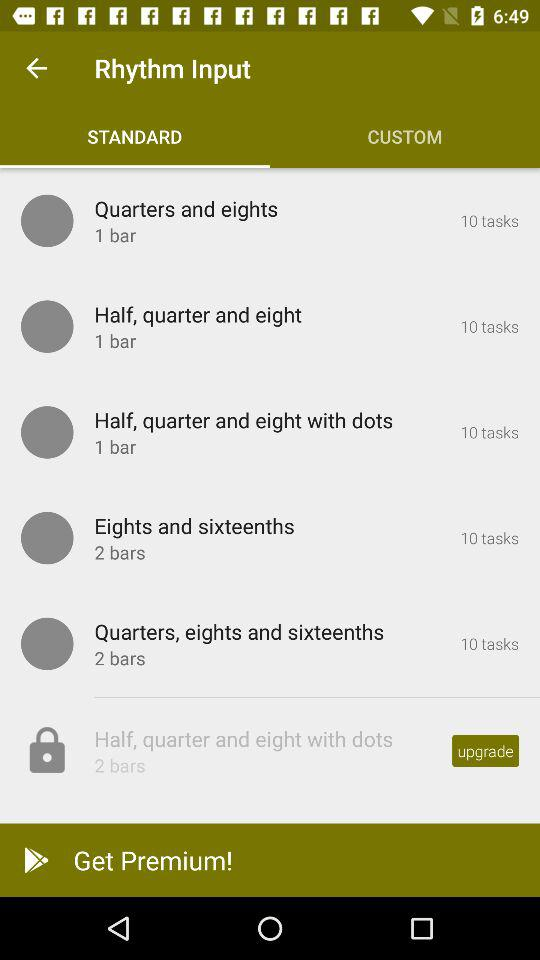What is the number of bars in "Half, quarter and eight with dots" having 10 tasks? The number of bars is 1. 